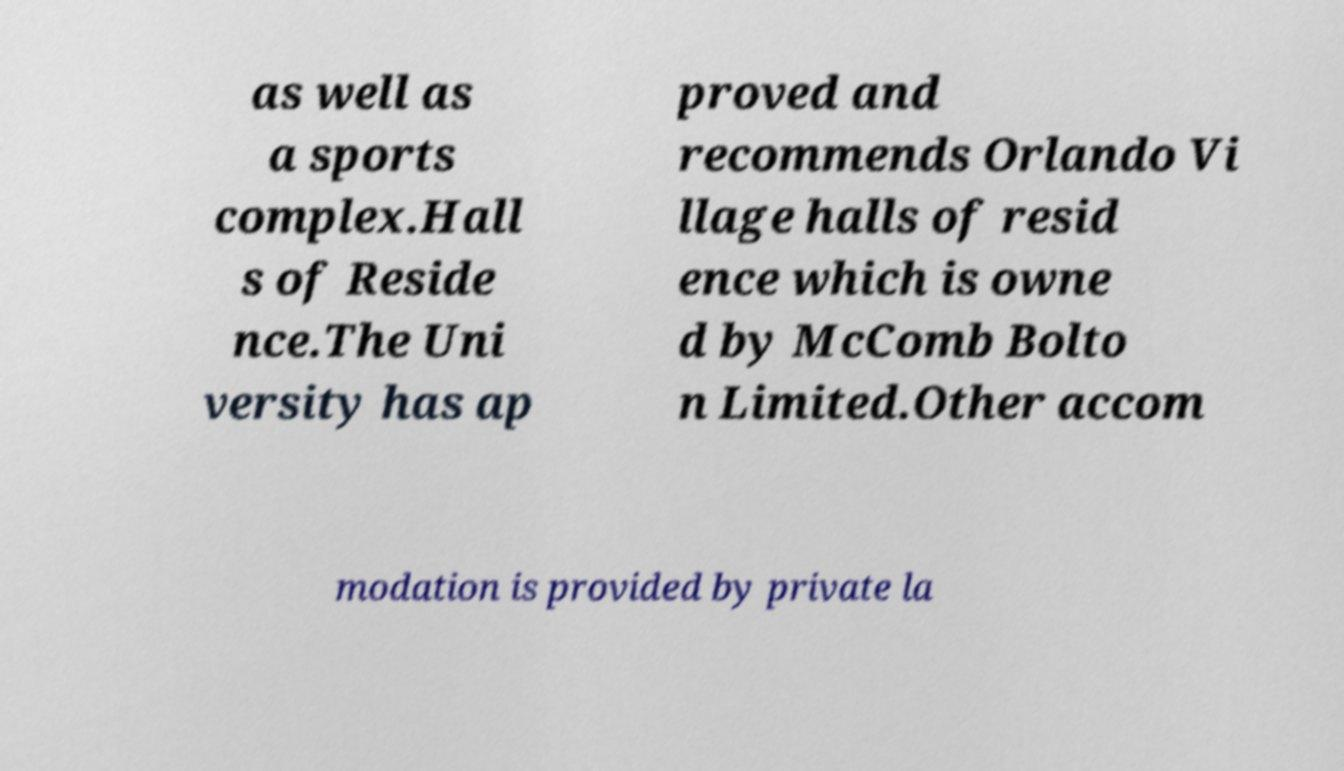Please read and relay the text visible in this image. What does it say? as well as a sports complex.Hall s of Reside nce.The Uni versity has ap proved and recommends Orlando Vi llage halls of resid ence which is owne d by McComb Bolto n Limited.Other accom modation is provided by private la 